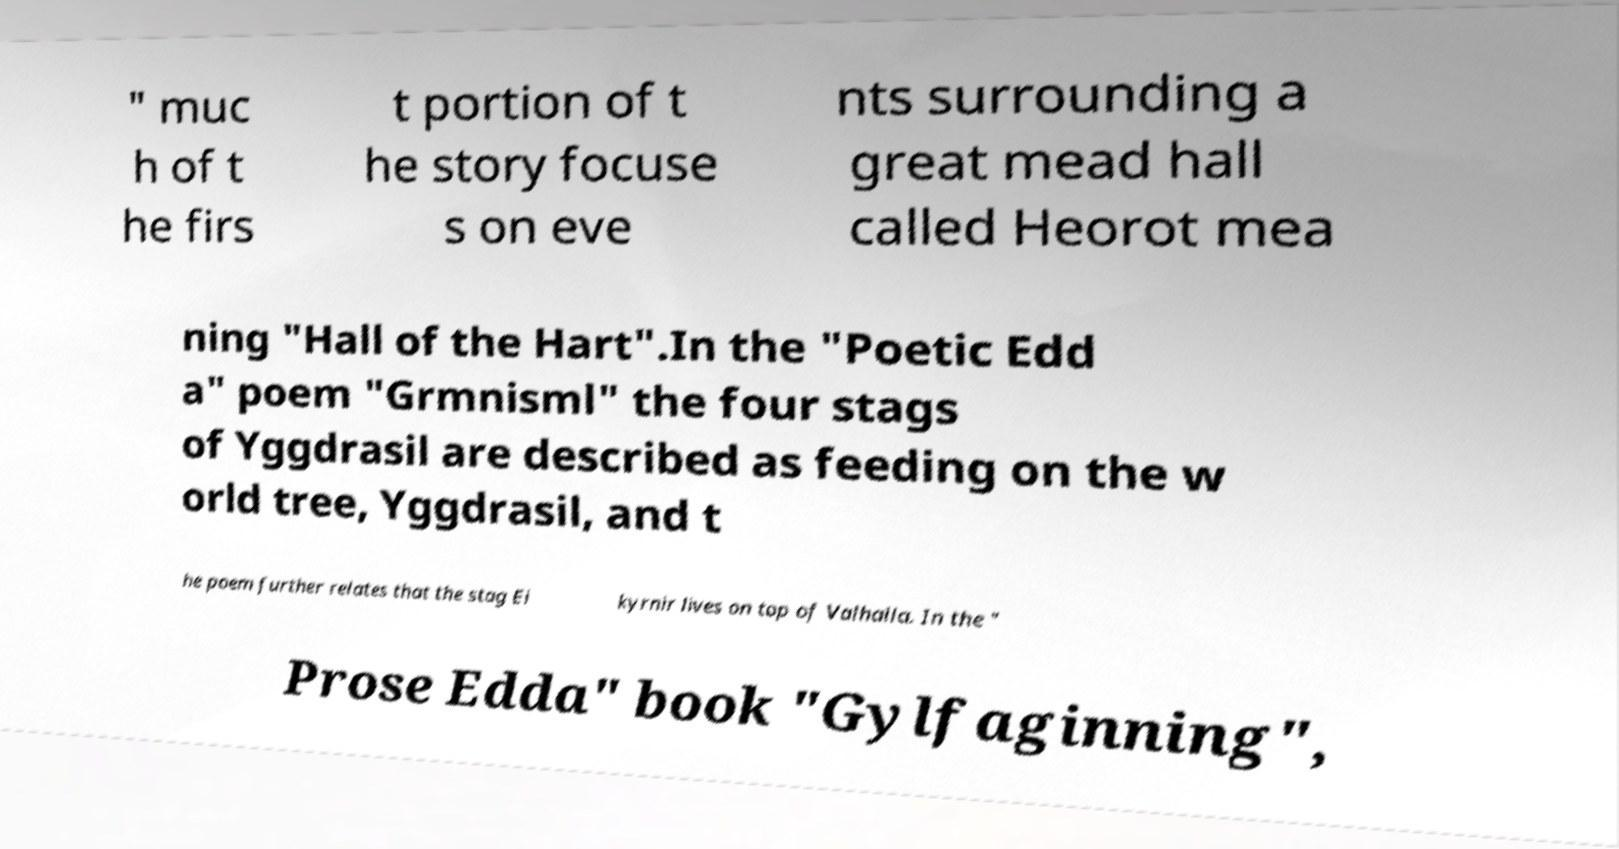Please read and relay the text visible in this image. What does it say? " muc h of t he firs t portion of t he story focuse s on eve nts surrounding a great mead hall called Heorot mea ning "Hall of the Hart".In the "Poetic Edd a" poem "Grmnisml" the four stags of Yggdrasil are described as feeding on the w orld tree, Yggdrasil, and t he poem further relates that the stag Ei kyrnir lives on top of Valhalla. In the " Prose Edda" book "Gylfaginning", 